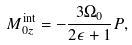<formula> <loc_0><loc_0><loc_500><loc_500>M _ { 0 z } ^ { \text {int} } = - \frac { 3 \Omega _ { 0 } } { 2 \epsilon + 1 } P ,</formula> 